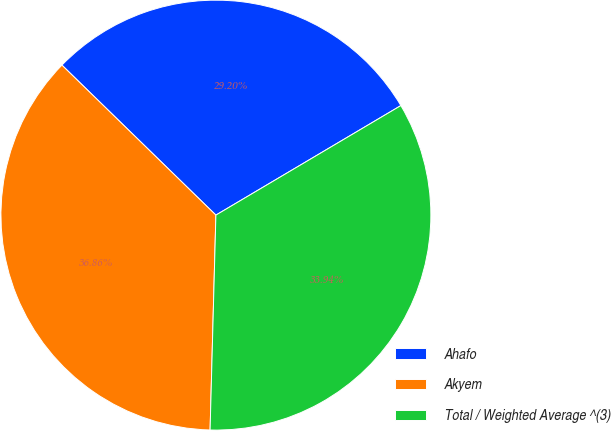Convert chart to OTSL. <chart><loc_0><loc_0><loc_500><loc_500><pie_chart><fcel>Ahafo<fcel>Akyem<fcel>Total / Weighted Average ^(3)<nl><fcel>29.2%<fcel>36.86%<fcel>33.94%<nl></chart> 